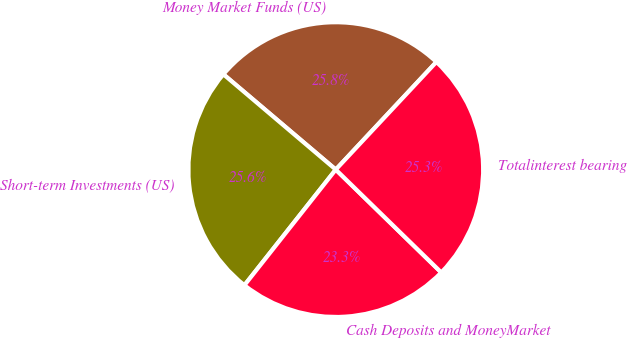Convert chart to OTSL. <chart><loc_0><loc_0><loc_500><loc_500><pie_chart><fcel>Money Market Funds (US)<fcel>Short-term Investments (US)<fcel>Cash Deposits and MoneyMarket<fcel>Totalinterest bearing<nl><fcel>25.77%<fcel>25.55%<fcel>23.34%<fcel>25.33%<nl></chart> 